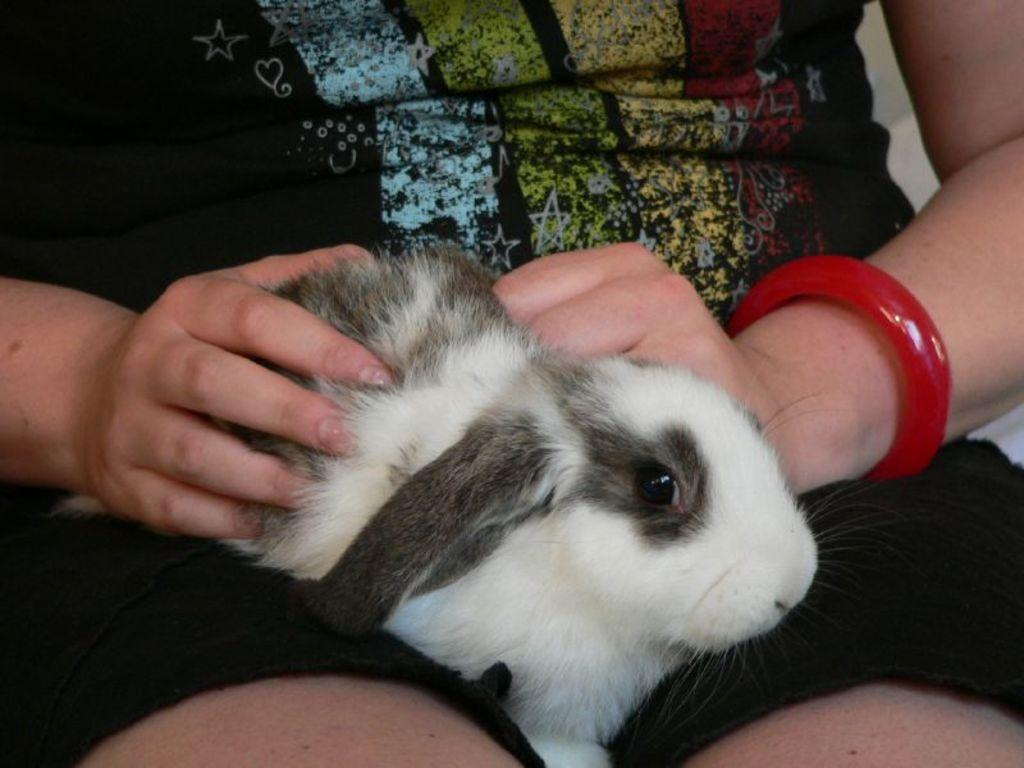What is the main subject of the image? There is a person in the image. What is the person holding in their hands? The person is holding a rabbit in their hands. Where is the rabbit resting in the image? The rabbit is resting on the person's legs. What is the price of the book on the page with the button in the image? There is no book, page, or button present in the image; it features a person holding a rabbit. 